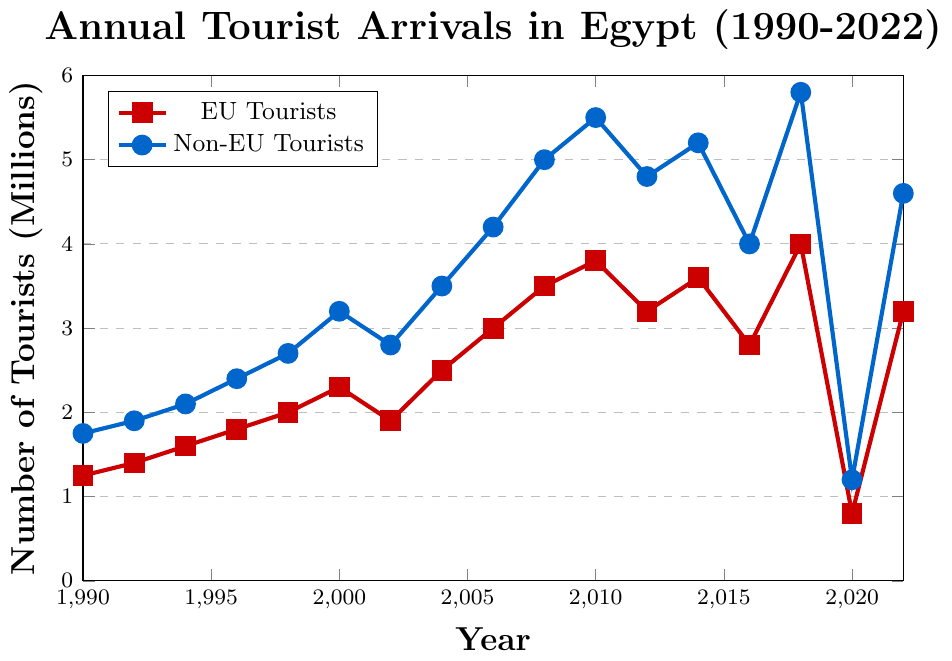What's the trend of non-EU tourist arrivals compared to EU tourist arrivals from 1990 to 2022? The trend shows that non-EU tourist arrivals are consistently higher than EU tourist arrivals throughout the period. Non-EU tourists increase at a faster rate and sustain higher numbers, except for notable drops in 2020 for both groups.
Answer: Non-EU tourists have a higher trend than EU tourists Which year saw the highest number of non-EU tourists, and how many were there? By examining the peaks in the blue line, 2018 saw the highest number of non-EU tourists. The value for that year is approximately 5.8 million non-EU tourists.
Answer: 2018, 5.8 million In which year did the EU tourists experience the sharpest drop, and what was the decrease? Comparing the slopes, 2016 shows a sharp drop from 2014, decreasing from 3.6 million to 2.8 million. The decrease is 3.6 - 2.8 = 0.8 million.
Answer: 2016, 0.8 million decrease What is the relationship between EU tourist arrivals in 2000 and 2002? The red line indicates EU tourists decreased between 2000 (2.3 million) and 2002 (1.9 million). The decrease is 2.3 - 1.9 = 0.4 million.
Answer: EU tourist arrivals decreased by 0.4 million How did non-EU tourist numbers recover after the sharp decrease in 2020? The blue line shows a significant decrease in 2020 to 1.2 million followed by a recovery to 4.6 million in 2022. The increase is 4.6 - 1.2 = 3.4 million.
Answer: Recovered by 3.4 million Which year had the closest number of EU and non-EU tourists, and what were the numbers? Examining both lines, 2020 had the closest numbers with EU tourists at 0.8 million and non-EU tourists at 1.2 million.
Answer: 2020, EU: 0.8 million, Non-EU: 1.2 million In what years did EU tourist arrivals surpass 3 million? Observing the red line's crossing points, EU tourist arrivals surpass 3 million in 2006, 2008, 2010, 2014, and 2018.
Answer: 2006, 2008, 2010, 2014, 2018 How much did non-EU tourist arrivals grow between 1990 and 2008? The blue line starts at 1.75 million in 1990 and grows to 5 million in 2008. The increase is 5 - 1.75 = 3.25 million.
Answer: Grew by 3.25 million What is the average number of EU tourists between 2010 and 2022? The values for EU tourists in this period are: 3.8, 3.2, 3.6, 2.8, 4, 0.8, 3.2 million. Summing these and dividing by the number of years gives: (3.8 + 3.2 + 3.6 + 2.8 + 4 + 0.8 + 3.2) / 7 = 3.06 million.
Answer: 3.06 million Are non-EU tourists affected equally by the same events as EU tourists? Use 2011 and 2020 as examples. In 2012, both groups show a drop with EU tourists from 3.8 million to 3.2 million and non-EU tourists from 5.5 million to 4.8 million. In 2020, both groups dramatically decrease, EU from 4 million to 0.8 million, non-EU from 5.8 million to 1.2 million. Thus, both groups are similarly affected by global or regional events.
Answer: Yes, they are similarly affected 